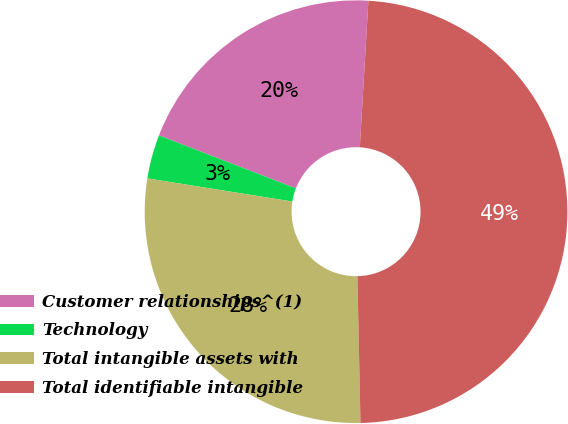Convert chart. <chart><loc_0><loc_0><loc_500><loc_500><pie_chart><fcel>Customer relationships^(1)<fcel>Technology<fcel>Total intangible assets with<fcel>Total identifiable intangible<nl><fcel>20.05%<fcel>3.36%<fcel>27.85%<fcel>48.73%<nl></chart> 